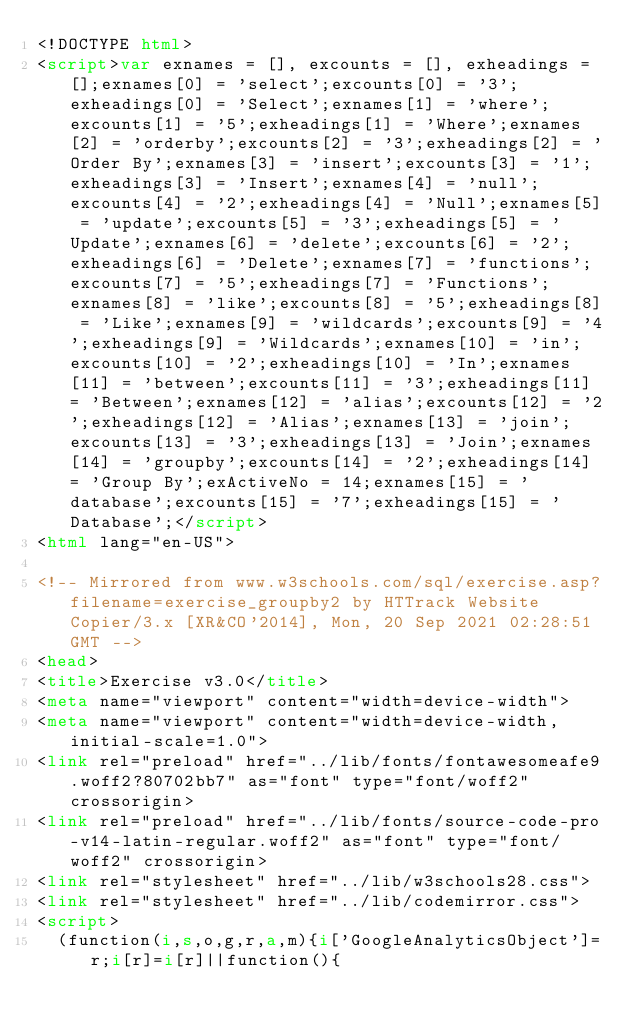Convert code to text. <code><loc_0><loc_0><loc_500><loc_500><_HTML_><!DOCTYPE html>
<script>var exnames = [], excounts = [], exheadings = [];exnames[0] = 'select';excounts[0] = '3';exheadings[0] = 'Select';exnames[1] = 'where';excounts[1] = '5';exheadings[1] = 'Where';exnames[2] = 'orderby';excounts[2] = '3';exheadings[2] = 'Order By';exnames[3] = 'insert';excounts[3] = '1';exheadings[3] = 'Insert';exnames[4] = 'null';excounts[4] = '2';exheadings[4] = 'Null';exnames[5] = 'update';excounts[5] = '3';exheadings[5] = 'Update';exnames[6] = 'delete';excounts[6] = '2';exheadings[6] = 'Delete';exnames[7] = 'functions';excounts[7] = '5';exheadings[7] = 'Functions';exnames[8] = 'like';excounts[8] = '5';exheadings[8] = 'Like';exnames[9] = 'wildcards';excounts[9] = '4';exheadings[9] = 'Wildcards';exnames[10] = 'in';excounts[10] = '2';exheadings[10] = 'In';exnames[11] = 'between';excounts[11] = '3';exheadings[11] = 'Between';exnames[12] = 'alias';excounts[12] = '2';exheadings[12] = 'Alias';exnames[13] = 'join';excounts[13] = '3';exheadings[13] = 'Join';exnames[14] = 'groupby';excounts[14] = '2';exheadings[14] = 'Group By';exActiveNo = 14;exnames[15] = 'database';excounts[15] = '7';exheadings[15] = 'Database';</script>
<html lang="en-US">

<!-- Mirrored from www.w3schools.com/sql/exercise.asp?filename=exercise_groupby2 by HTTrack Website Copier/3.x [XR&CO'2014], Mon, 20 Sep 2021 02:28:51 GMT -->
<head>
<title>Exercise v3.0</title>
<meta name="viewport" content="width=device-width">
<meta name="viewport" content="width=device-width, initial-scale=1.0">
<link rel="preload" href="../lib/fonts/fontawesomeafe9.woff2?80702bb7" as="font" type="font/woff2" crossorigin> 
<link rel="preload" href="../lib/fonts/source-code-pro-v14-latin-regular.woff2" as="font" type="font/woff2" crossorigin> 
<link rel="stylesheet" href="../lib/w3schools28.css">
<link rel="stylesheet" href="../lib/codemirror.css">
<script>
  (function(i,s,o,g,r,a,m){i['GoogleAnalyticsObject']=r;i[r]=i[r]||function(){</code> 